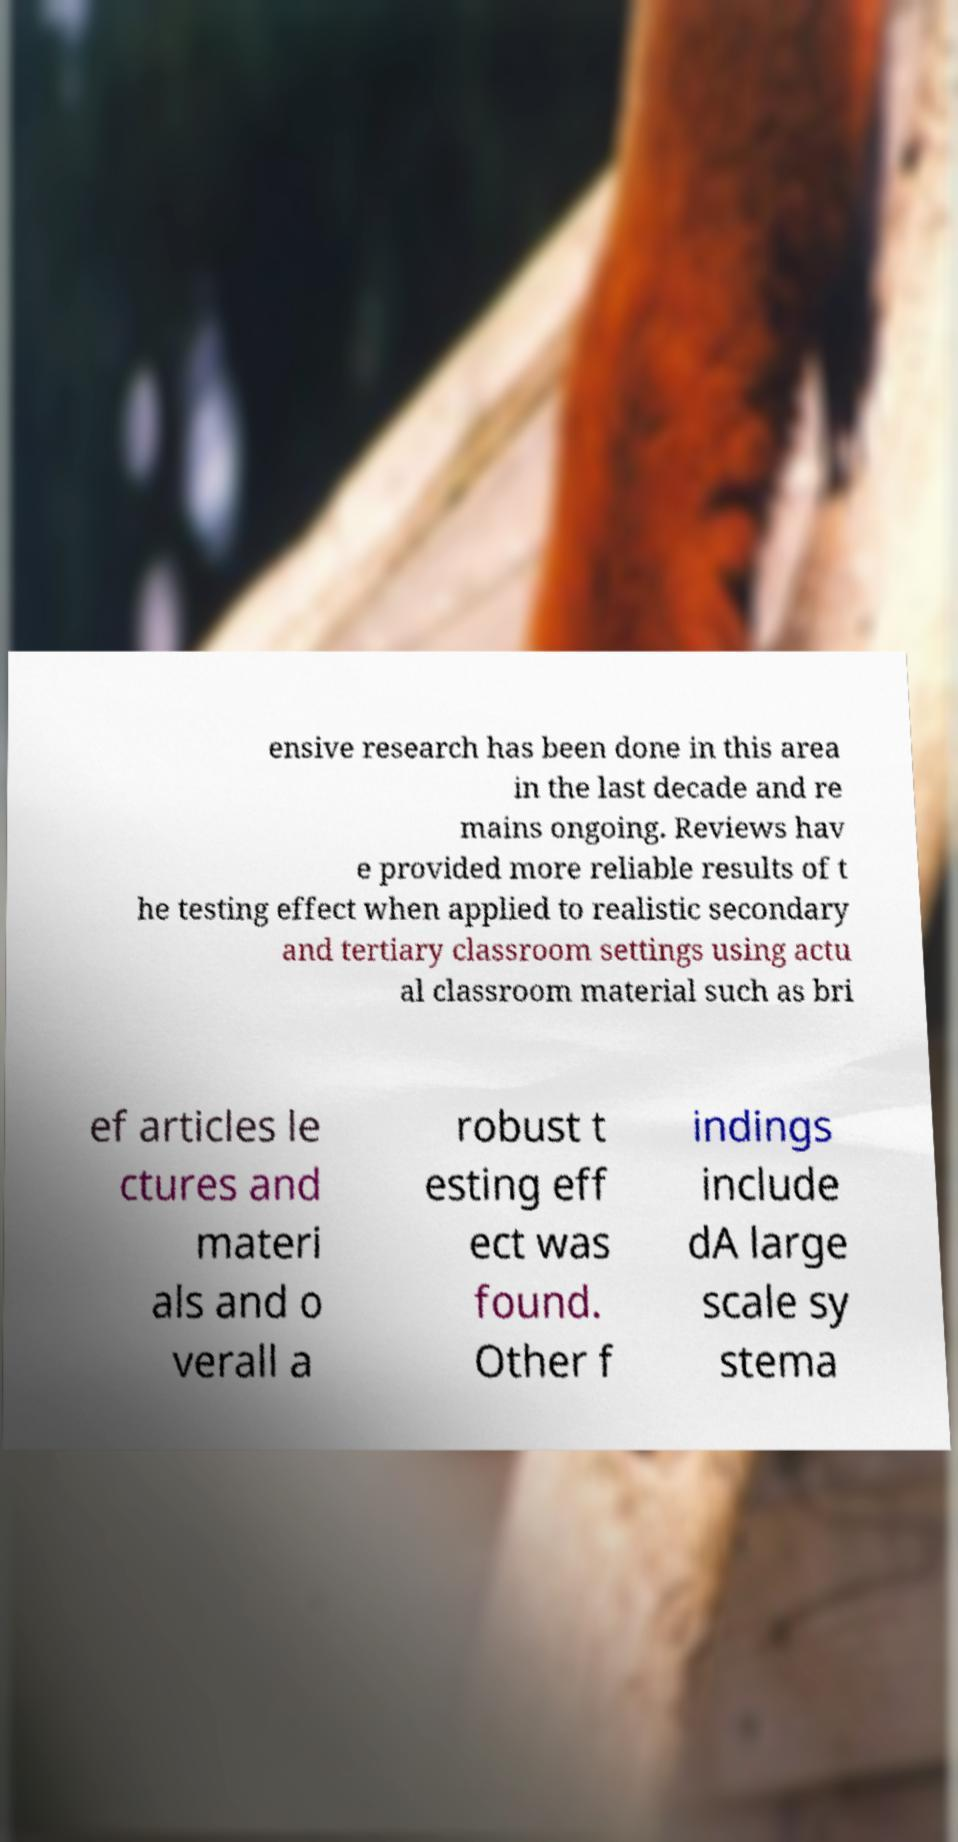Can you read and provide the text displayed in the image?This photo seems to have some interesting text. Can you extract and type it out for me? ensive research has been done in this area in the last decade and re mains ongoing. Reviews hav e provided more reliable results of t he testing effect when applied to realistic secondary and tertiary classroom settings using actu al classroom material such as bri ef articles le ctures and materi als and o verall a robust t esting eff ect was found. Other f indings include dA large scale sy stema 